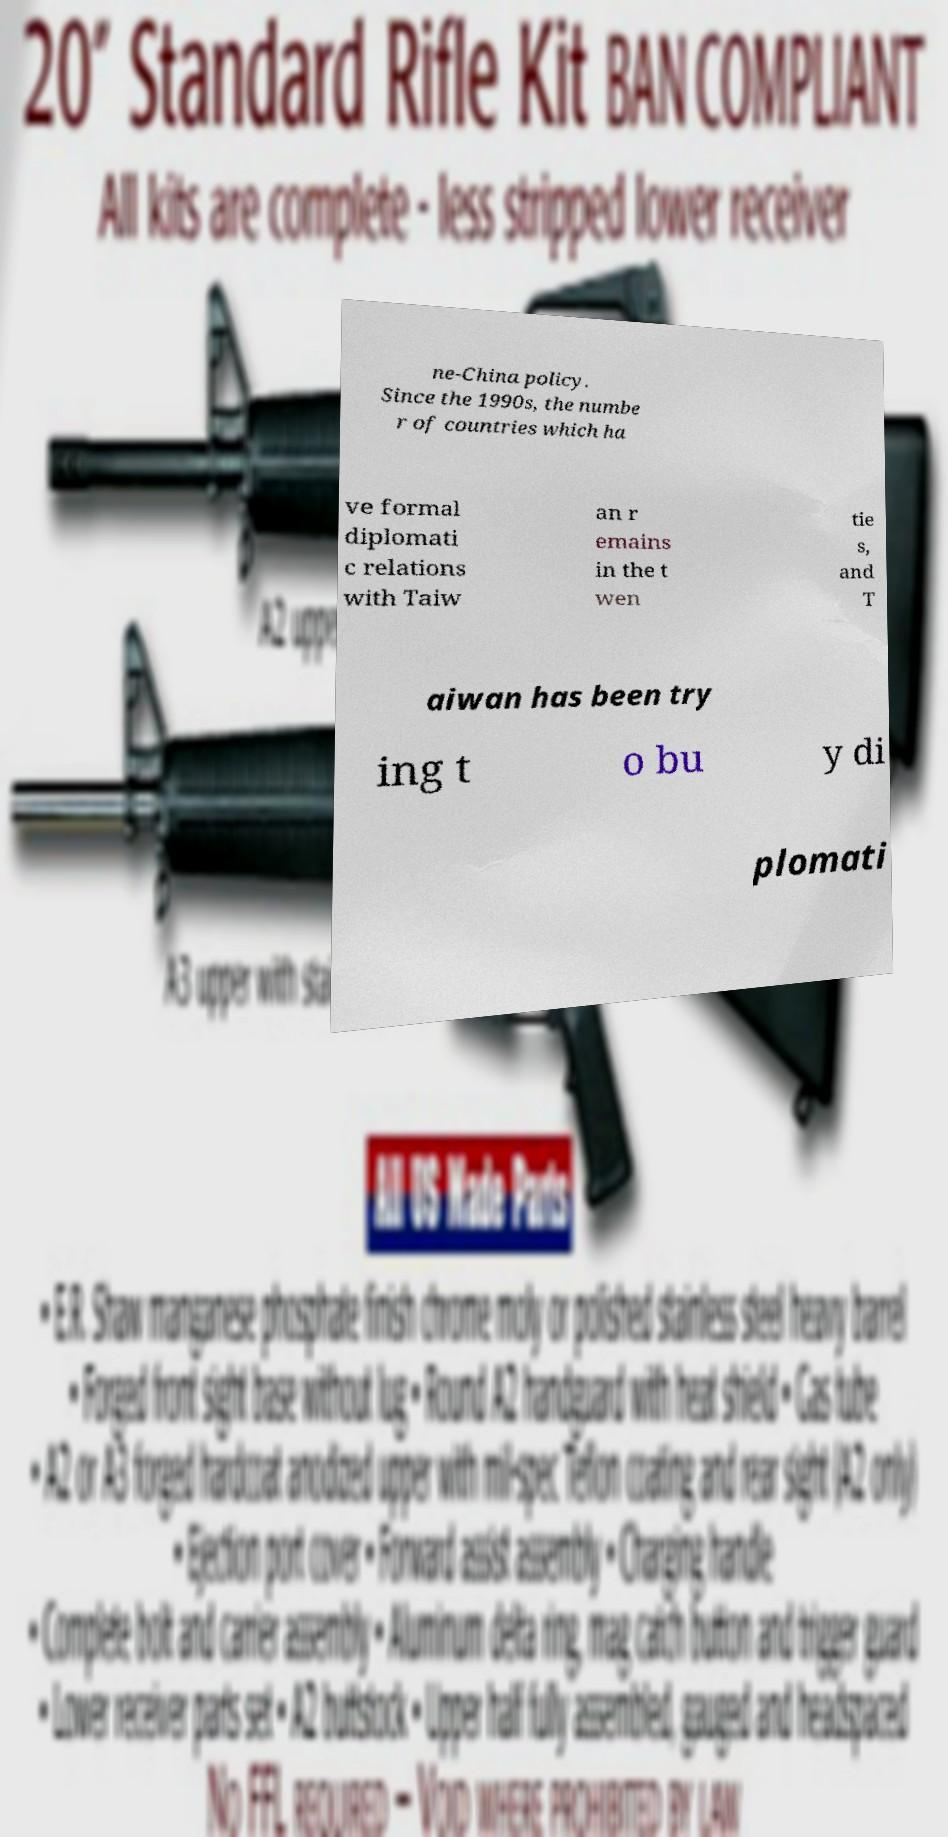Could you assist in decoding the text presented in this image and type it out clearly? ne-China policy. Since the 1990s, the numbe r of countries which ha ve formal diplomati c relations with Taiw an r emains in the t wen tie s, and T aiwan has been try ing t o bu y di plomati 